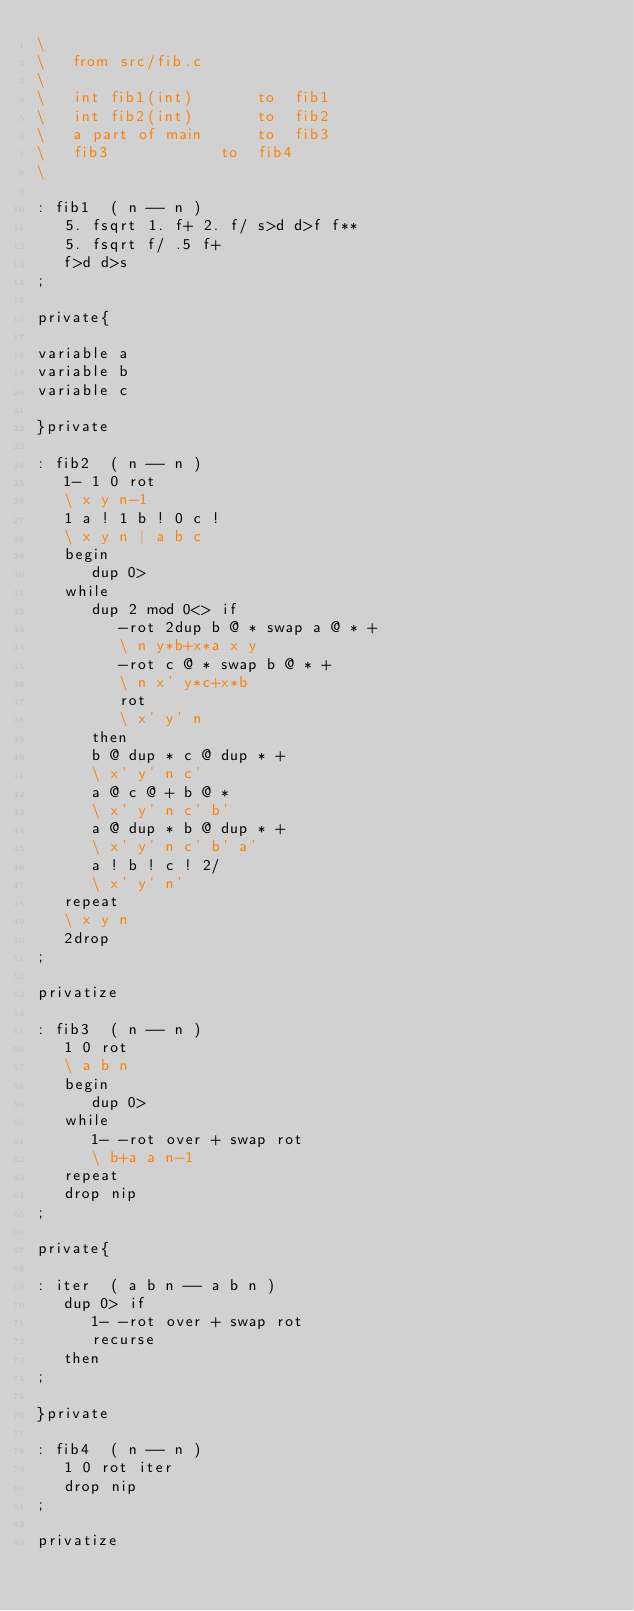Convert code to text. <code><loc_0><loc_0><loc_500><loc_500><_Forth_>\
\	from src/fib.c
\
\	int fib1(int)		to	fib1
\	int fib2(int)		to	fib2
\	a part of main		to	fib3
\	fib3			to	fib4
\

: fib1  ( n -- n )
   5. fsqrt 1. f+ 2. f/ s>d d>f f**
   5. fsqrt f/ .5 f+
   f>d d>s
;

private{

variable a
variable b
variable c

}private

: fib2  ( n -- n )
   1- 1 0 rot
   \ x y n-1
   1 a ! 1 b ! 0 c !
   \ x y n | a b c
   begin
      dup 0>
   while
      dup 2 mod 0<> if
         -rot 2dup b @ * swap a @ * +
         \ n y*b+x*a x y
         -rot c @ * swap b @ * +
         \ n x' y*c+x*b
         rot
         \ x' y' n
      then
      b @ dup * c @ dup * +
      \ x' y' n c'
      a @ c @ + b @ *
      \ x' y' n c' b'
      a @ dup * b @ dup * +
      \ x' y' n c' b' a'
      a ! b ! c ! 2/
      \ x' y' n'
   repeat
   \ x y n
   2drop
;

privatize

: fib3  ( n -- n )
   1 0 rot
   \ a b n
   begin
      dup 0>
   while
      1- -rot over + swap rot
      \ b+a a n-1
   repeat
   drop nip
;

private{

: iter  ( a b n -- a b n )
   dup 0> if
      1- -rot over + swap rot
      recurse
   then
;

}private

: fib4  ( n -- n )
   1 0 rot iter
   drop nip
;

privatize
</code> 